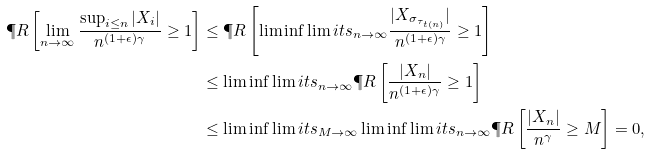<formula> <loc_0><loc_0><loc_500><loc_500>\P R \left [ \lim _ { n \to \infty } \frac { \sup _ { i \leq n } | X _ { i } | } { n ^ { ( 1 + \epsilon ) \gamma } } \geq 1 \right ] & \leq \P R \left [ \liminf \lim i t s _ { n \to \infty } \frac { | X _ { \sigma _ { \tau _ { t ( n ) } } } | } { n ^ { ( 1 + \epsilon ) \gamma } } \geq 1 \right ] \\ & \leq \liminf \lim i t s _ { n \to \infty } \P R \left [ \frac { | X _ { n } | } { n ^ { ( 1 + \epsilon ) \gamma } } \geq 1 \right ] \\ & \leq \liminf \lim i t s _ { M \to \infty } \liminf \lim i t s _ { n \to \infty } \P R \left [ \frac { | X _ { n } | } { n ^ { \gamma } } \geq M \right ] = 0 ,</formula> 